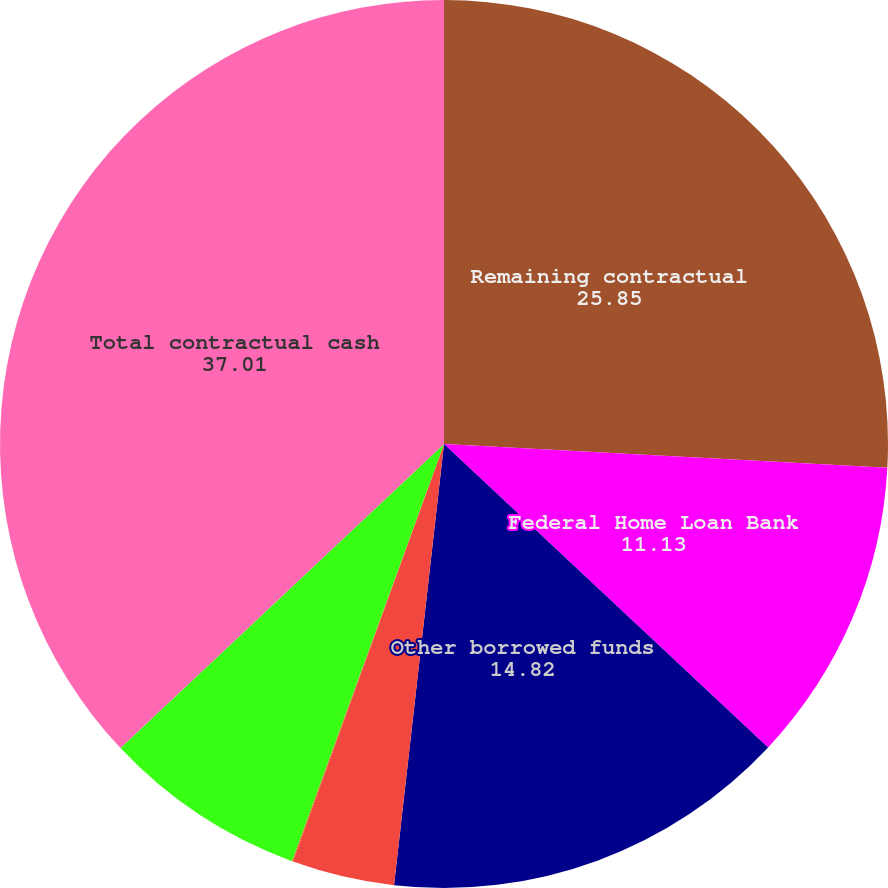<chart> <loc_0><loc_0><loc_500><loc_500><pie_chart><fcel>Remaining contractual<fcel>Federal Home Loan Bank<fcel>Other borrowed funds<fcel>Minimum annual rentals on<fcel>Nonqualified pension and<fcel>Purchase obligations (a)<fcel>Total contractual cash<nl><fcel>25.85%<fcel>11.13%<fcel>14.82%<fcel>3.73%<fcel>0.04%<fcel>7.43%<fcel>37.01%<nl></chart> 